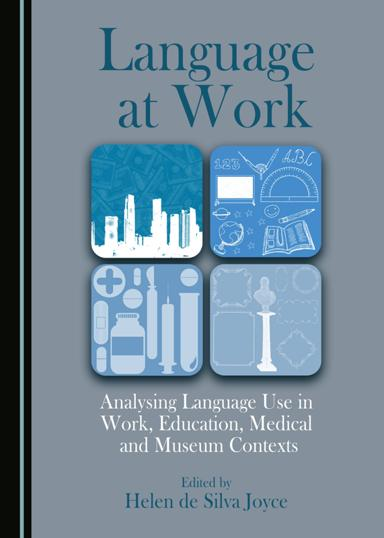What could be the potential audience or readership for this book? The potential audience for "Language at Work" likely includes professionals and academics in the fields of linguistics, communication studies, education, healthcare, and museum management. It would also appeal to anyone interested in understanding the practical applications of language analysis in various real-world settings. 